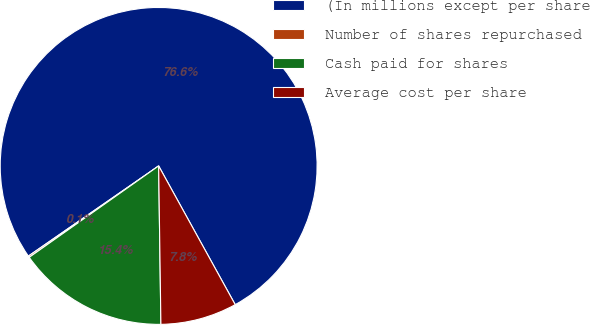Convert chart. <chart><loc_0><loc_0><loc_500><loc_500><pie_chart><fcel>(In millions except per share<fcel>Number of shares repurchased<fcel>Cash paid for shares<fcel>Average cost per share<nl><fcel>76.61%<fcel>0.15%<fcel>15.44%<fcel>7.8%<nl></chart> 